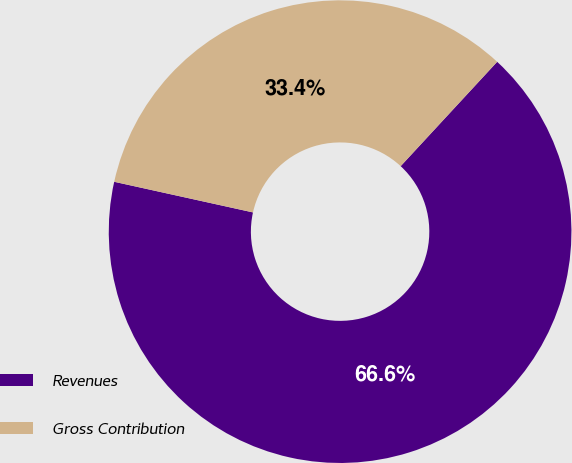Convert chart to OTSL. <chart><loc_0><loc_0><loc_500><loc_500><pie_chart><fcel>Revenues<fcel>Gross Contribution<nl><fcel>66.58%<fcel>33.42%<nl></chart> 